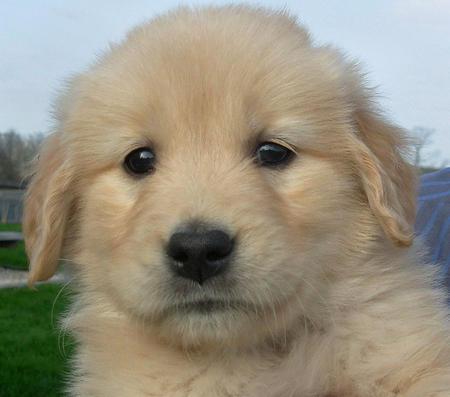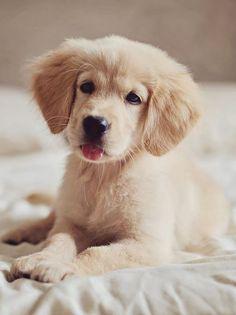The first image is the image on the left, the second image is the image on the right. Considering the images on both sides, is "In one of the images there are at least two puppies right next to each other." valid? Answer yes or no. No. The first image is the image on the left, the second image is the image on the right. Analyze the images presented: Is the assertion "There are at least three dogs." valid? Answer yes or no. No. 